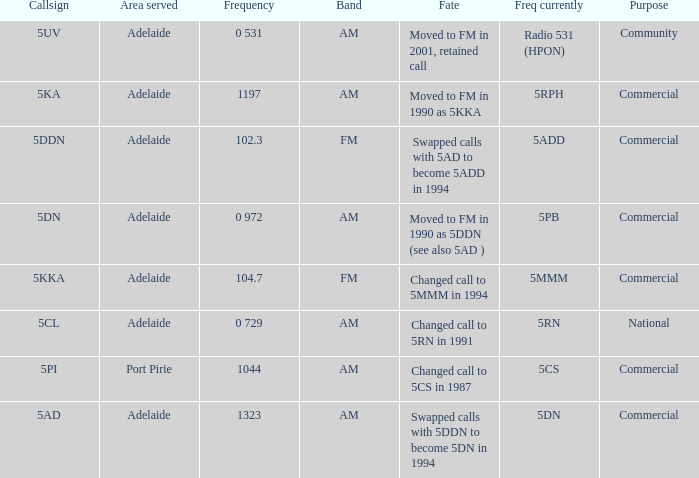Which area served has a Callsign of 5ddn? Adelaide. 